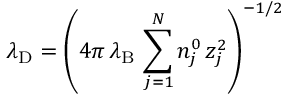Convert formula to latex. <formula><loc_0><loc_0><loc_500><loc_500>\lambda _ { D } = \left ( 4 \pi \, \lambda _ { B } \, \sum _ { j = 1 } ^ { N } n _ { j } ^ { 0 } \, z _ { j } ^ { 2 } \right ) ^ { - 1 / 2 }</formula> 